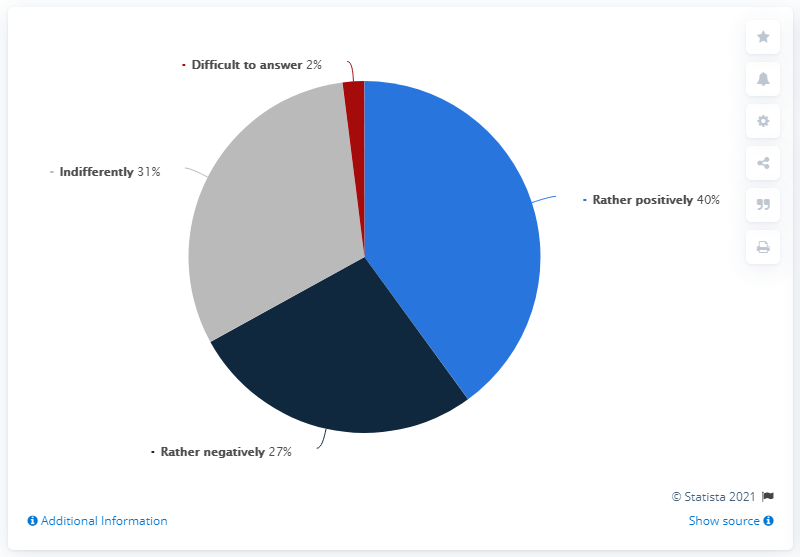Give some essential details in this illustration. Red indicates the least. The ratio of responses indicating 'Rather Positive' to those indicating 'Difficult to Answer' is approximately 20%. 